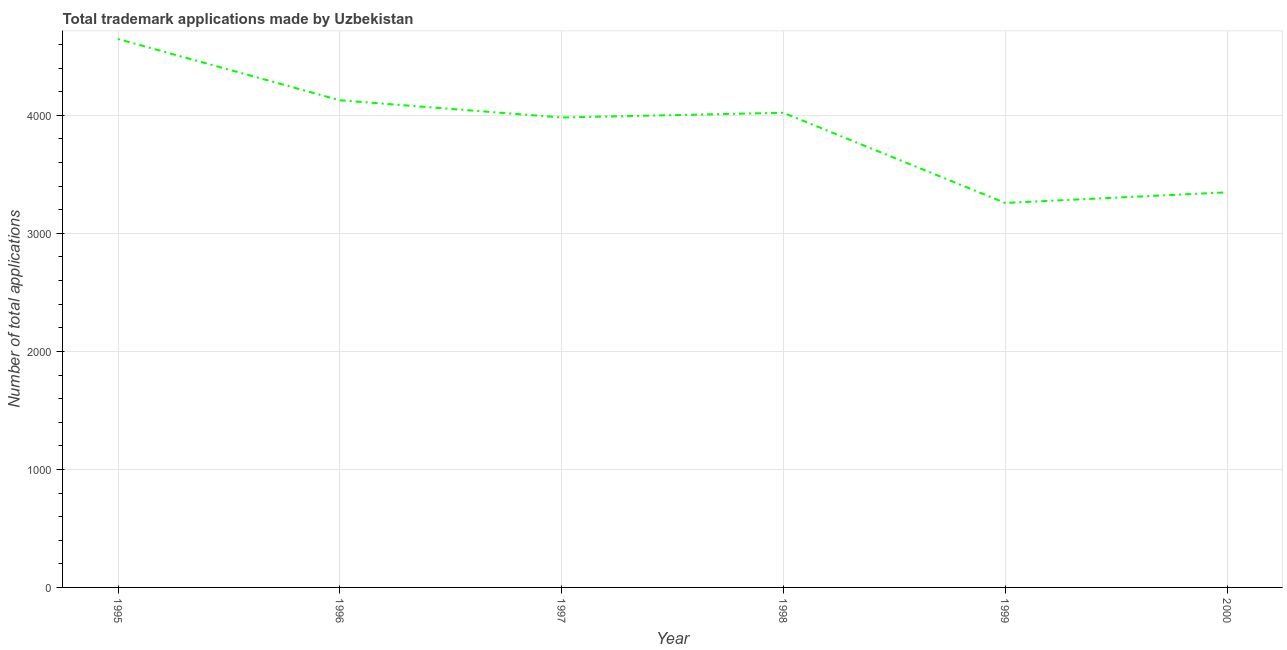What is the number of trademark applications in 1998?
Make the answer very short. 4022. Across all years, what is the maximum number of trademark applications?
Offer a very short reply. 4647. Across all years, what is the minimum number of trademark applications?
Your answer should be very brief. 3258. In which year was the number of trademark applications maximum?
Make the answer very short. 1995. In which year was the number of trademark applications minimum?
Offer a very short reply. 1999. What is the sum of the number of trademark applications?
Your answer should be compact. 2.34e+04. What is the difference between the number of trademark applications in 1998 and 2000?
Offer a terse response. 674. What is the average number of trademark applications per year?
Give a very brief answer. 3897.5. What is the median number of trademark applications?
Give a very brief answer. 4002. What is the ratio of the number of trademark applications in 1995 to that in 1997?
Provide a short and direct response. 1.17. Is the number of trademark applications in 1996 less than that in 1999?
Give a very brief answer. No. What is the difference between the highest and the second highest number of trademark applications?
Ensure brevity in your answer.  519. What is the difference between the highest and the lowest number of trademark applications?
Make the answer very short. 1389. In how many years, is the number of trademark applications greater than the average number of trademark applications taken over all years?
Keep it short and to the point. 4. How many years are there in the graph?
Your response must be concise. 6. What is the difference between two consecutive major ticks on the Y-axis?
Keep it short and to the point. 1000. Does the graph contain grids?
Provide a succinct answer. Yes. What is the title of the graph?
Your answer should be compact. Total trademark applications made by Uzbekistan. What is the label or title of the X-axis?
Provide a succinct answer. Year. What is the label or title of the Y-axis?
Your response must be concise. Number of total applications. What is the Number of total applications in 1995?
Ensure brevity in your answer.  4647. What is the Number of total applications in 1996?
Your answer should be compact. 4128. What is the Number of total applications of 1997?
Provide a succinct answer. 3982. What is the Number of total applications in 1998?
Your response must be concise. 4022. What is the Number of total applications of 1999?
Make the answer very short. 3258. What is the Number of total applications in 2000?
Keep it short and to the point. 3348. What is the difference between the Number of total applications in 1995 and 1996?
Your answer should be very brief. 519. What is the difference between the Number of total applications in 1995 and 1997?
Keep it short and to the point. 665. What is the difference between the Number of total applications in 1995 and 1998?
Provide a short and direct response. 625. What is the difference between the Number of total applications in 1995 and 1999?
Your answer should be very brief. 1389. What is the difference between the Number of total applications in 1995 and 2000?
Ensure brevity in your answer.  1299. What is the difference between the Number of total applications in 1996 and 1997?
Provide a short and direct response. 146. What is the difference between the Number of total applications in 1996 and 1998?
Provide a succinct answer. 106. What is the difference between the Number of total applications in 1996 and 1999?
Provide a succinct answer. 870. What is the difference between the Number of total applications in 1996 and 2000?
Offer a very short reply. 780. What is the difference between the Number of total applications in 1997 and 1998?
Make the answer very short. -40. What is the difference between the Number of total applications in 1997 and 1999?
Make the answer very short. 724. What is the difference between the Number of total applications in 1997 and 2000?
Make the answer very short. 634. What is the difference between the Number of total applications in 1998 and 1999?
Provide a succinct answer. 764. What is the difference between the Number of total applications in 1998 and 2000?
Your response must be concise. 674. What is the difference between the Number of total applications in 1999 and 2000?
Make the answer very short. -90. What is the ratio of the Number of total applications in 1995 to that in 1996?
Your answer should be very brief. 1.13. What is the ratio of the Number of total applications in 1995 to that in 1997?
Keep it short and to the point. 1.17. What is the ratio of the Number of total applications in 1995 to that in 1998?
Offer a terse response. 1.16. What is the ratio of the Number of total applications in 1995 to that in 1999?
Make the answer very short. 1.43. What is the ratio of the Number of total applications in 1995 to that in 2000?
Your answer should be very brief. 1.39. What is the ratio of the Number of total applications in 1996 to that in 1998?
Offer a terse response. 1.03. What is the ratio of the Number of total applications in 1996 to that in 1999?
Give a very brief answer. 1.27. What is the ratio of the Number of total applications in 1996 to that in 2000?
Your answer should be compact. 1.23. What is the ratio of the Number of total applications in 1997 to that in 1999?
Your response must be concise. 1.22. What is the ratio of the Number of total applications in 1997 to that in 2000?
Provide a succinct answer. 1.19. What is the ratio of the Number of total applications in 1998 to that in 1999?
Your answer should be very brief. 1.23. What is the ratio of the Number of total applications in 1998 to that in 2000?
Offer a very short reply. 1.2. What is the ratio of the Number of total applications in 1999 to that in 2000?
Your answer should be compact. 0.97. 